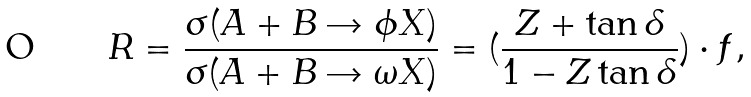Convert formula to latex. <formula><loc_0><loc_0><loc_500><loc_500>R = \frac { \sigma ( A + B \rightarrow \phi X ) } { \sigma ( A + B \rightarrow \omega X ) } = ( \frac { Z + \tan { \delta } } { 1 - Z \tan { \delta } } ) \cdot f ,</formula> 